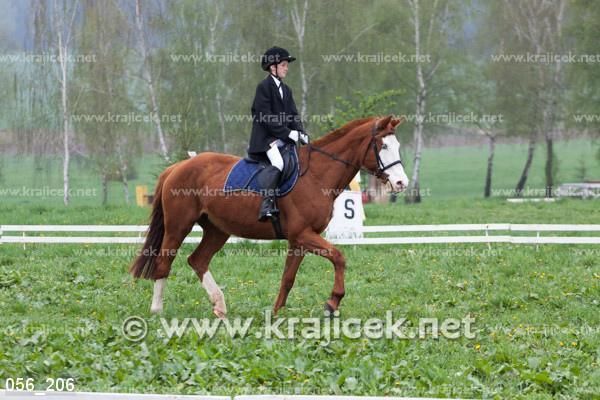What sport is this?
Choose the right answer and clarify with the format: 'Answer: answer
Rationale: rationale.'
Options: Volleyball, tennis, equestrian, baseball. Answer: equestrian.
Rationale: The person in the uniform with a helmet on a horse suggest the sport. 